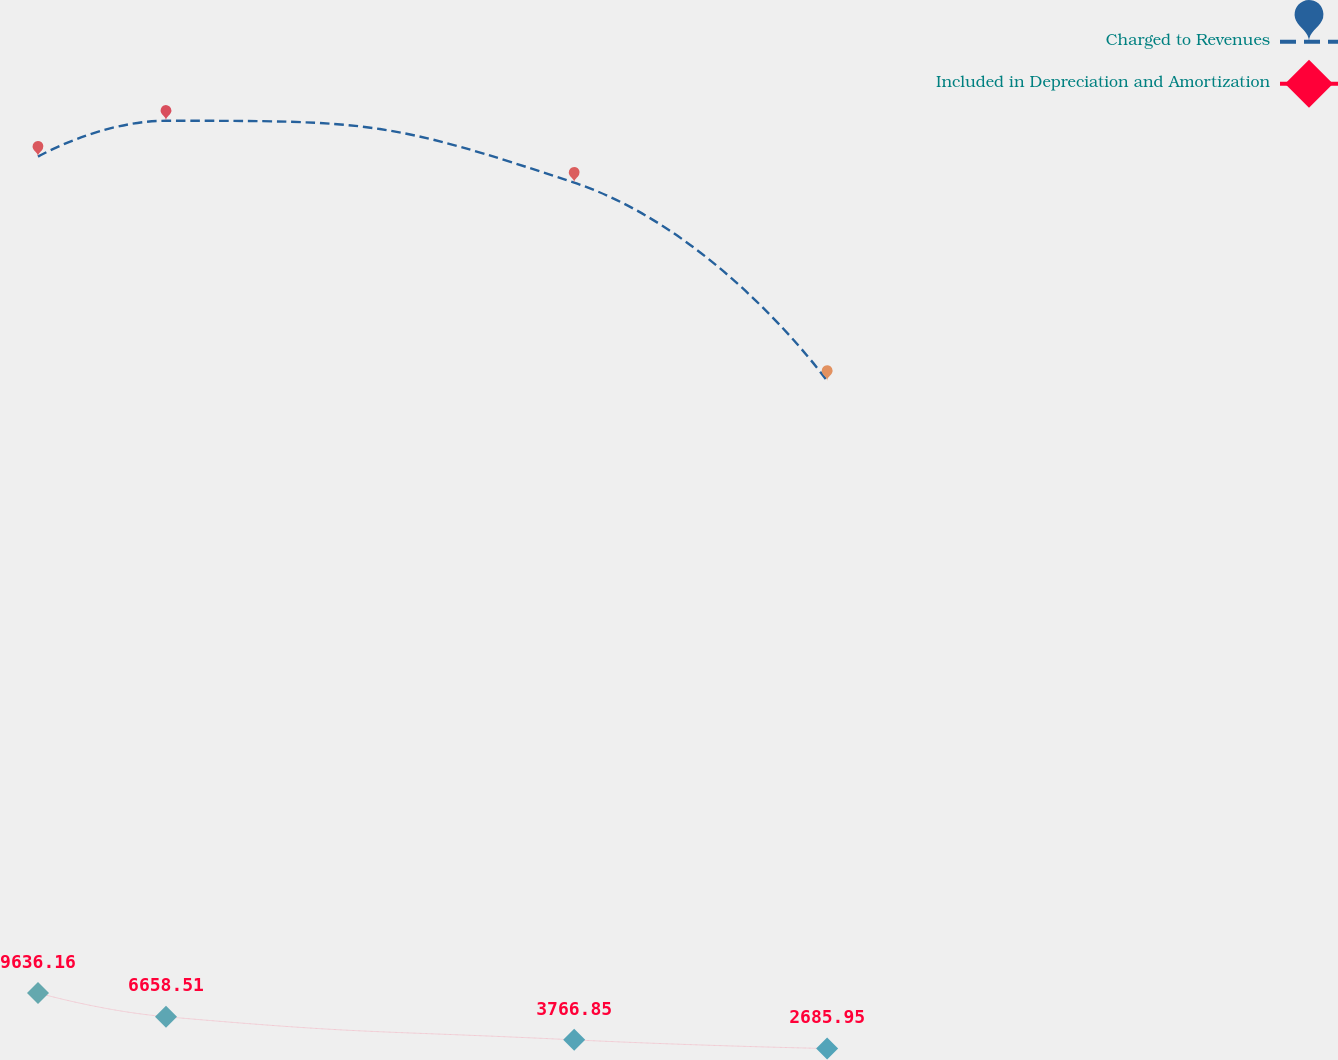<chart> <loc_0><loc_0><loc_500><loc_500><line_chart><ecel><fcel>Charged to Revenues<fcel>Included in Depreciation and Amortization<nl><fcel>1772.43<fcel>114168<fcel>9636.16<nl><fcel>1801.84<fcel>118653<fcel>6658.51<nl><fcel>1895.64<fcel>110917<fcel>3766.85<nl><fcel>1953.76<fcel>86143.3<fcel>2685.95<nl><fcel>2066.55<fcel>105238<fcel>1864.67<nl></chart> 